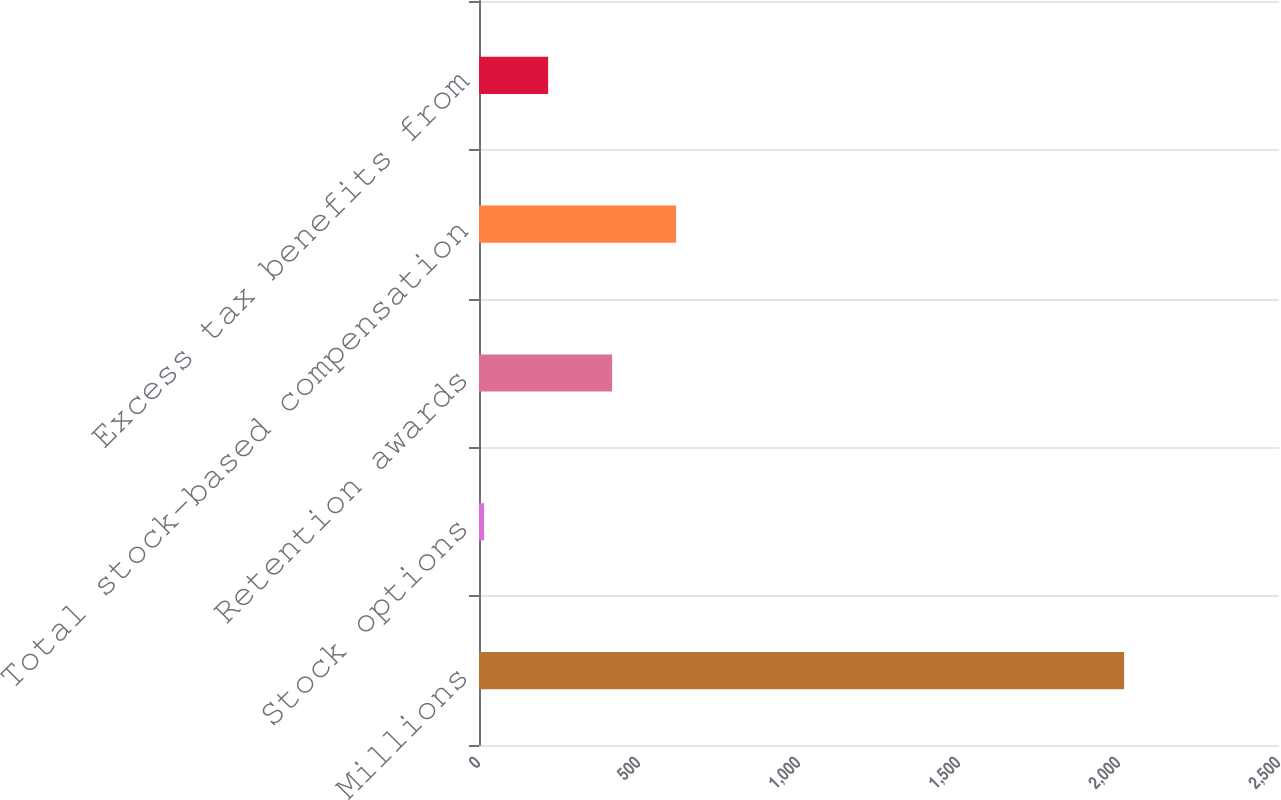Convert chart to OTSL. <chart><loc_0><loc_0><loc_500><loc_500><bar_chart><fcel>Millions<fcel>Stock options<fcel>Retention awards<fcel>Total stock-based compensation<fcel>Excess tax benefits from<nl><fcel>2016<fcel>16<fcel>416<fcel>616<fcel>216<nl></chart> 